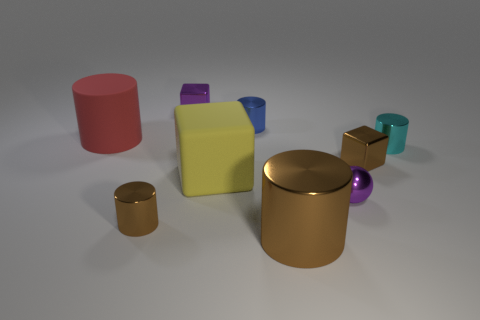There is a metallic thing that is the same color as the metal ball; what is its shape?
Your answer should be very brief. Cube. What material is the tiny brown thing that is the same shape as the cyan metallic object?
Keep it short and to the point. Metal. What number of balls are brown metallic objects or large yellow rubber things?
Your answer should be very brief. 0. How many large red cylinders have the same material as the small brown block?
Give a very brief answer. 0. Do the brown cylinder that is left of the big brown metallic object and the small purple object that is behind the cyan thing have the same material?
Your answer should be compact. Yes. What number of purple shiny things are in front of the tiny metal cube behind the tiny brown metallic object that is to the right of the blue metal thing?
Your response must be concise. 1. Does the large object in front of the ball have the same color as the rubber object in front of the big matte cylinder?
Offer a very short reply. No. Is there anything else that is the same color as the metal ball?
Provide a succinct answer. Yes. The matte thing that is right of the tiny brown metal thing that is on the left side of the big brown object is what color?
Your answer should be compact. Yellow. Are there any large purple blocks?
Give a very brief answer. No. 